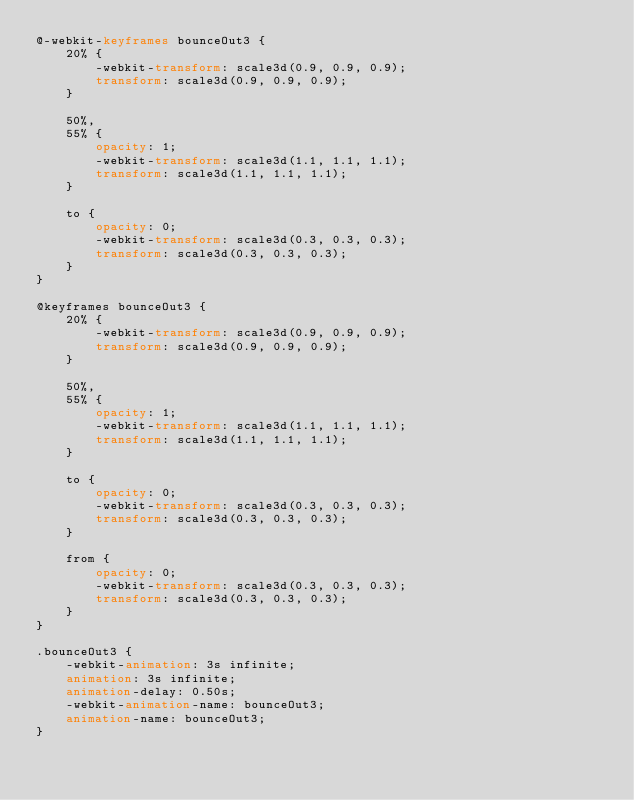<code> <loc_0><loc_0><loc_500><loc_500><_CSS_>@-webkit-keyframes bounceOut3 {
    20% {
        -webkit-transform: scale3d(0.9, 0.9, 0.9);
        transform: scale3d(0.9, 0.9, 0.9);
    }

    50%,
    55% {
        opacity: 1;
        -webkit-transform: scale3d(1.1, 1.1, 1.1);
        transform: scale3d(1.1, 1.1, 1.1);
    }

    to {
        opacity: 0;
        -webkit-transform: scale3d(0.3, 0.3, 0.3);
        transform: scale3d(0.3, 0.3, 0.3);
    }
}

@keyframes bounceOut3 {
    20% {
        -webkit-transform: scale3d(0.9, 0.9, 0.9);
        transform: scale3d(0.9, 0.9, 0.9);
    }

    50%,
    55% {
        opacity: 1;
        -webkit-transform: scale3d(1.1, 1.1, 1.1);
        transform: scale3d(1.1, 1.1, 1.1);
    }

    to {
        opacity: 0;
        -webkit-transform: scale3d(0.3, 0.3, 0.3);
        transform: scale3d(0.3, 0.3, 0.3);
    }

    from {
        opacity: 0;
        -webkit-transform: scale3d(0.3, 0.3, 0.3);
        transform: scale3d(0.3, 0.3, 0.3);
    }
}

.bounceOut3 {
    -webkit-animation: 3s infinite;
    animation: 3s infinite;
    animation-delay: 0.50s;
    -webkit-animation-name: bounceOut3;
    animation-name: bounceOut3;
}</code> 